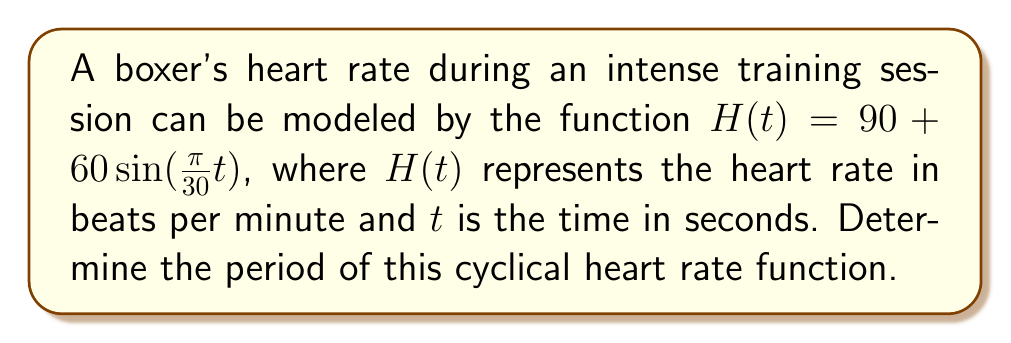Could you help me with this problem? To find the period of this cyclical function, we need to follow these steps:

1) The general form of a sine function is:
   $f(t) = A \sin(Bt) + C$
   where $B$ determines the period.

2) In our function $H(t) = 90 + 60\sin(\frac{\pi}{30}t)$, we can identify that $B = \frac{\pi}{30}$.

3) The period of a sine function is given by the formula:
   $\text{Period} = \frac{2\pi}{|B|}$

4) Substituting our value of $B$:
   $\text{Period} = \frac{2\pi}{|\frac{\pi}{30}|}$

5) Simplify:
   $\text{Period} = \frac{2\pi}{\frac{\pi}{30}} = 2\pi \cdot \frac{30}{\pi} = 60$ seconds

Therefore, the heart rate completes one full cycle every 60 seconds during this intense training session.
Answer: 60 seconds 